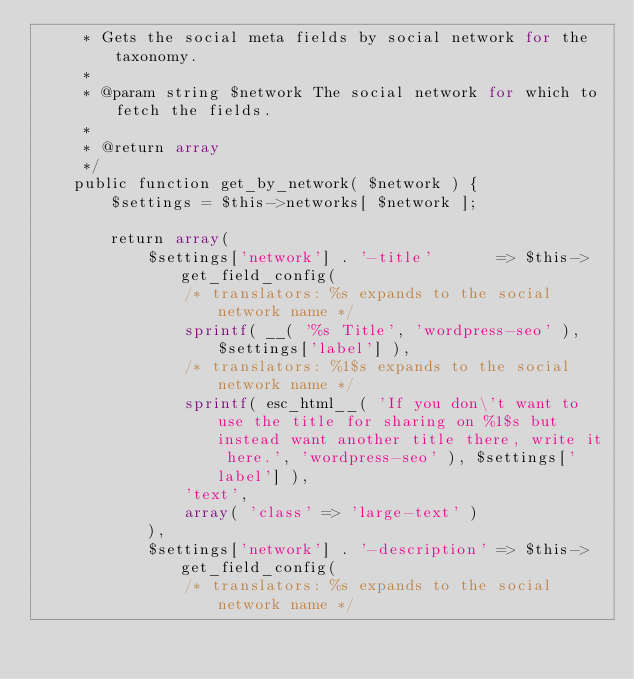<code> <loc_0><loc_0><loc_500><loc_500><_PHP_>	 * Gets the social meta fields by social network for the taxonomy.
	 *
	 * @param string $network The social network for which to fetch the fields.
	 *
	 * @return array
	 */
	public function get_by_network( $network ) {
		$settings = $this->networks[ $network ];

		return array(
			$settings['network'] . '-title'       => $this->get_field_config(
				/* translators: %s expands to the social network name */
				sprintf( __( '%s Title', 'wordpress-seo' ), $settings['label'] ),
				/* translators: %1$s expands to the social network name */
				sprintf( esc_html__( 'If you don\'t want to use the title for sharing on %1$s but instead want another title there, write it here.', 'wordpress-seo' ), $settings['label'] ),
				'text',
				array( 'class' => 'large-text' )
			),
			$settings['network'] . '-description' => $this->get_field_config(
				/* translators: %s expands to the social network name */</code> 